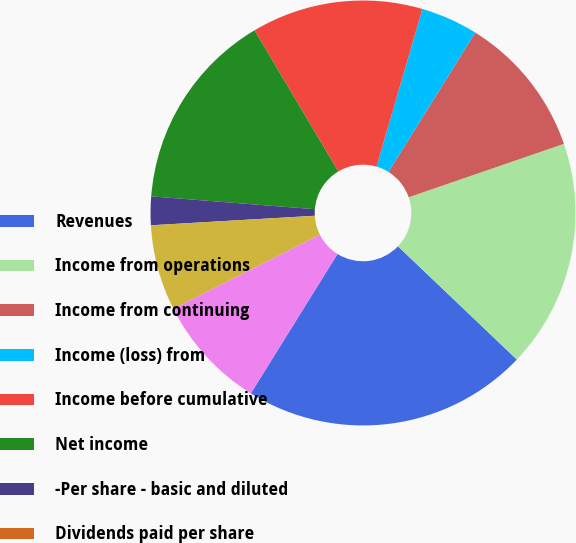Convert chart. <chart><loc_0><loc_0><loc_500><loc_500><pie_chart><fcel>Revenues<fcel>Income from operations<fcel>Income from continuing<fcel>Income (loss) from<fcel>Income before cumulative<fcel>Net income<fcel>-Per share - basic and diluted<fcel>Dividends paid per share<fcel>-Low<fcel>-High<nl><fcel>21.74%<fcel>17.39%<fcel>10.87%<fcel>4.35%<fcel>13.04%<fcel>15.22%<fcel>2.17%<fcel>0.0%<fcel>6.52%<fcel>8.7%<nl></chart> 